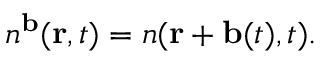Convert formula to latex. <formula><loc_0><loc_0><loc_500><loc_500>n ^ { b } ( { r } , t ) = n ( { r } + { b } ( t ) , t ) .</formula> 